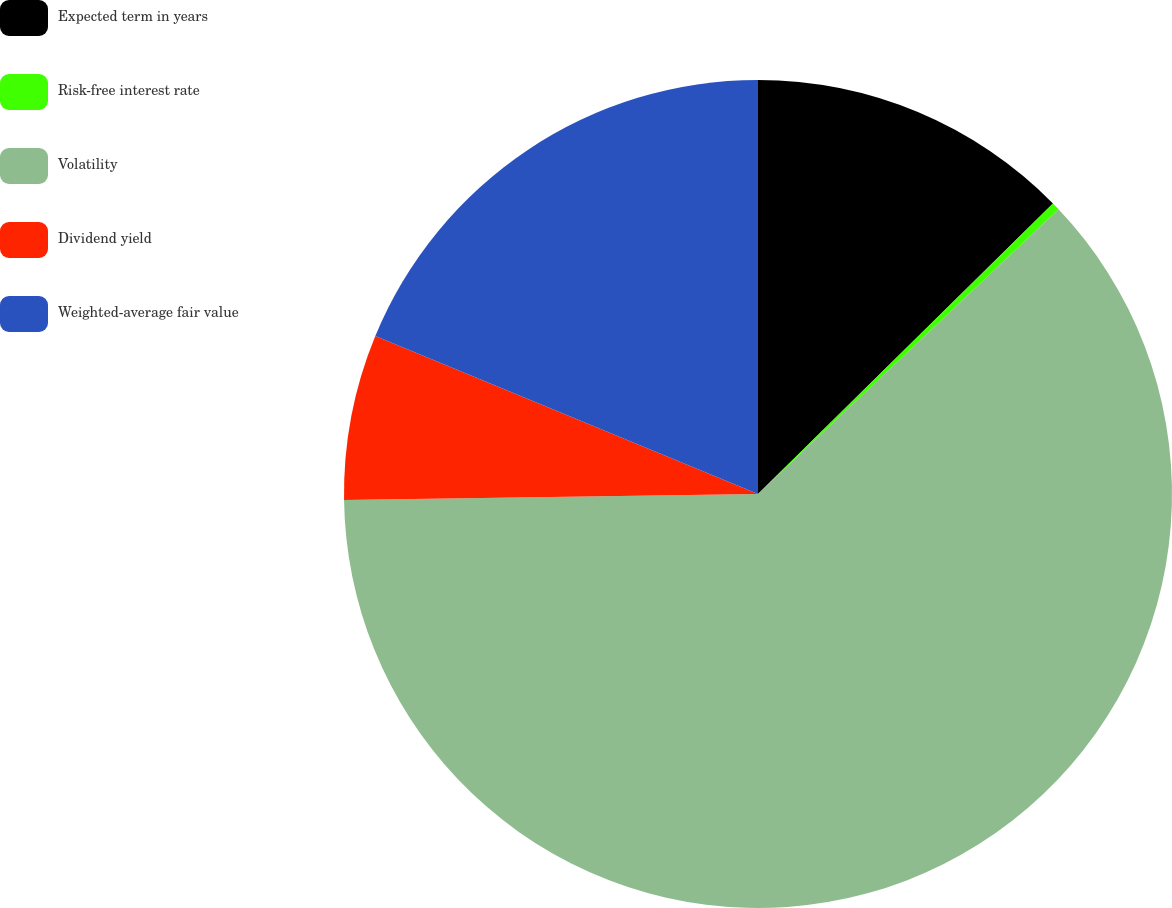Convert chart. <chart><loc_0><loc_0><loc_500><loc_500><pie_chart><fcel>Expected term in years<fcel>Risk-free interest rate<fcel>Volatility<fcel>Dividend yield<fcel>Weighted-average fair value<nl><fcel>12.62%<fcel>0.31%<fcel>61.84%<fcel>6.46%<fcel>18.77%<nl></chart> 